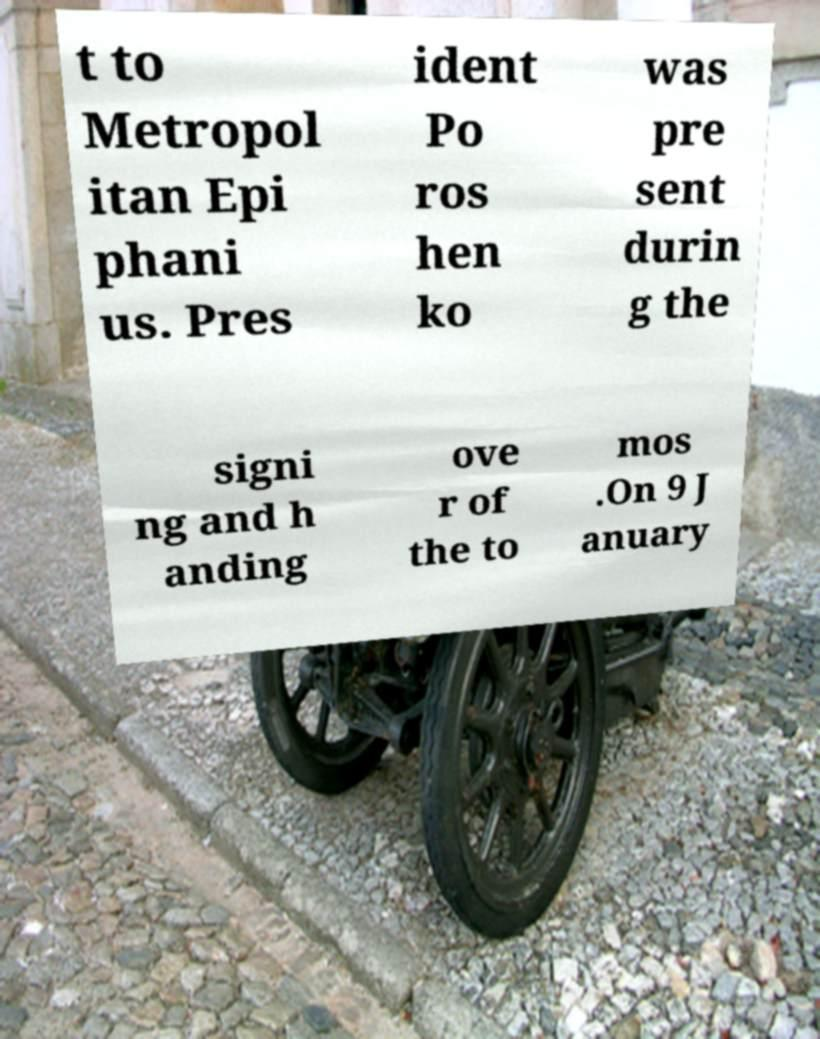Could you extract and type out the text from this image? t to Metropol itan Epi phani us. Pres ident Po ros hen ko was pre sent durin g the signi ng and h anding ove r of the to mos .On 9 J anuary 